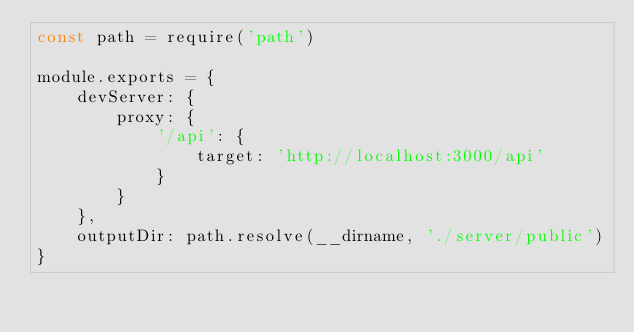Convert code to text. <code><loc_0><loc_0><loc_500><loc_500><_JavaScript_>const path = require('path')

module.exports = {
    devServer: {
        proxy: {
            '/api': {
                target: 'http://localhost:3000/api'
            }
        }
    },
    outputDir: path.resolve(__dirname, './server/public')
}
</code> 